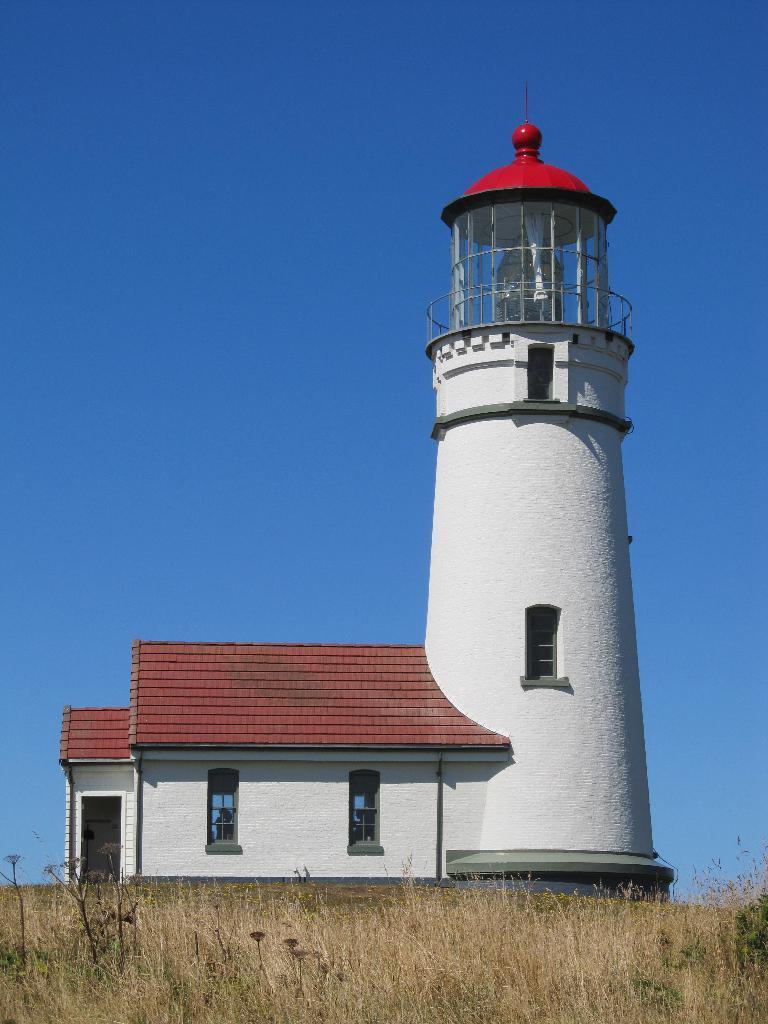Could you give a brief overview of what you see in this image? In the center of the image, we can see a lighthouse and at the bottom, there is ground covered with grass. At the top, there is sky. 